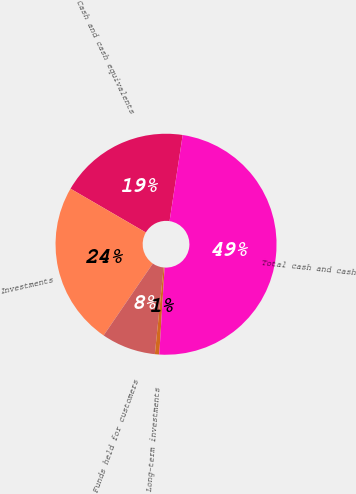Convert chart. <chart><loc_0><loc_0><loc_500><loc_500><pie_chart><fcel>Cash and cash equivalents<fcel>Investments<fcel>Funds held for customers<fcel>Long-term investments<fcel>Total cash and cash<nl><fcel>19.03%<fcel>23.83%<fcel>7.94%<fcel>0.64%<fcel>48.57%<nl></chart> 